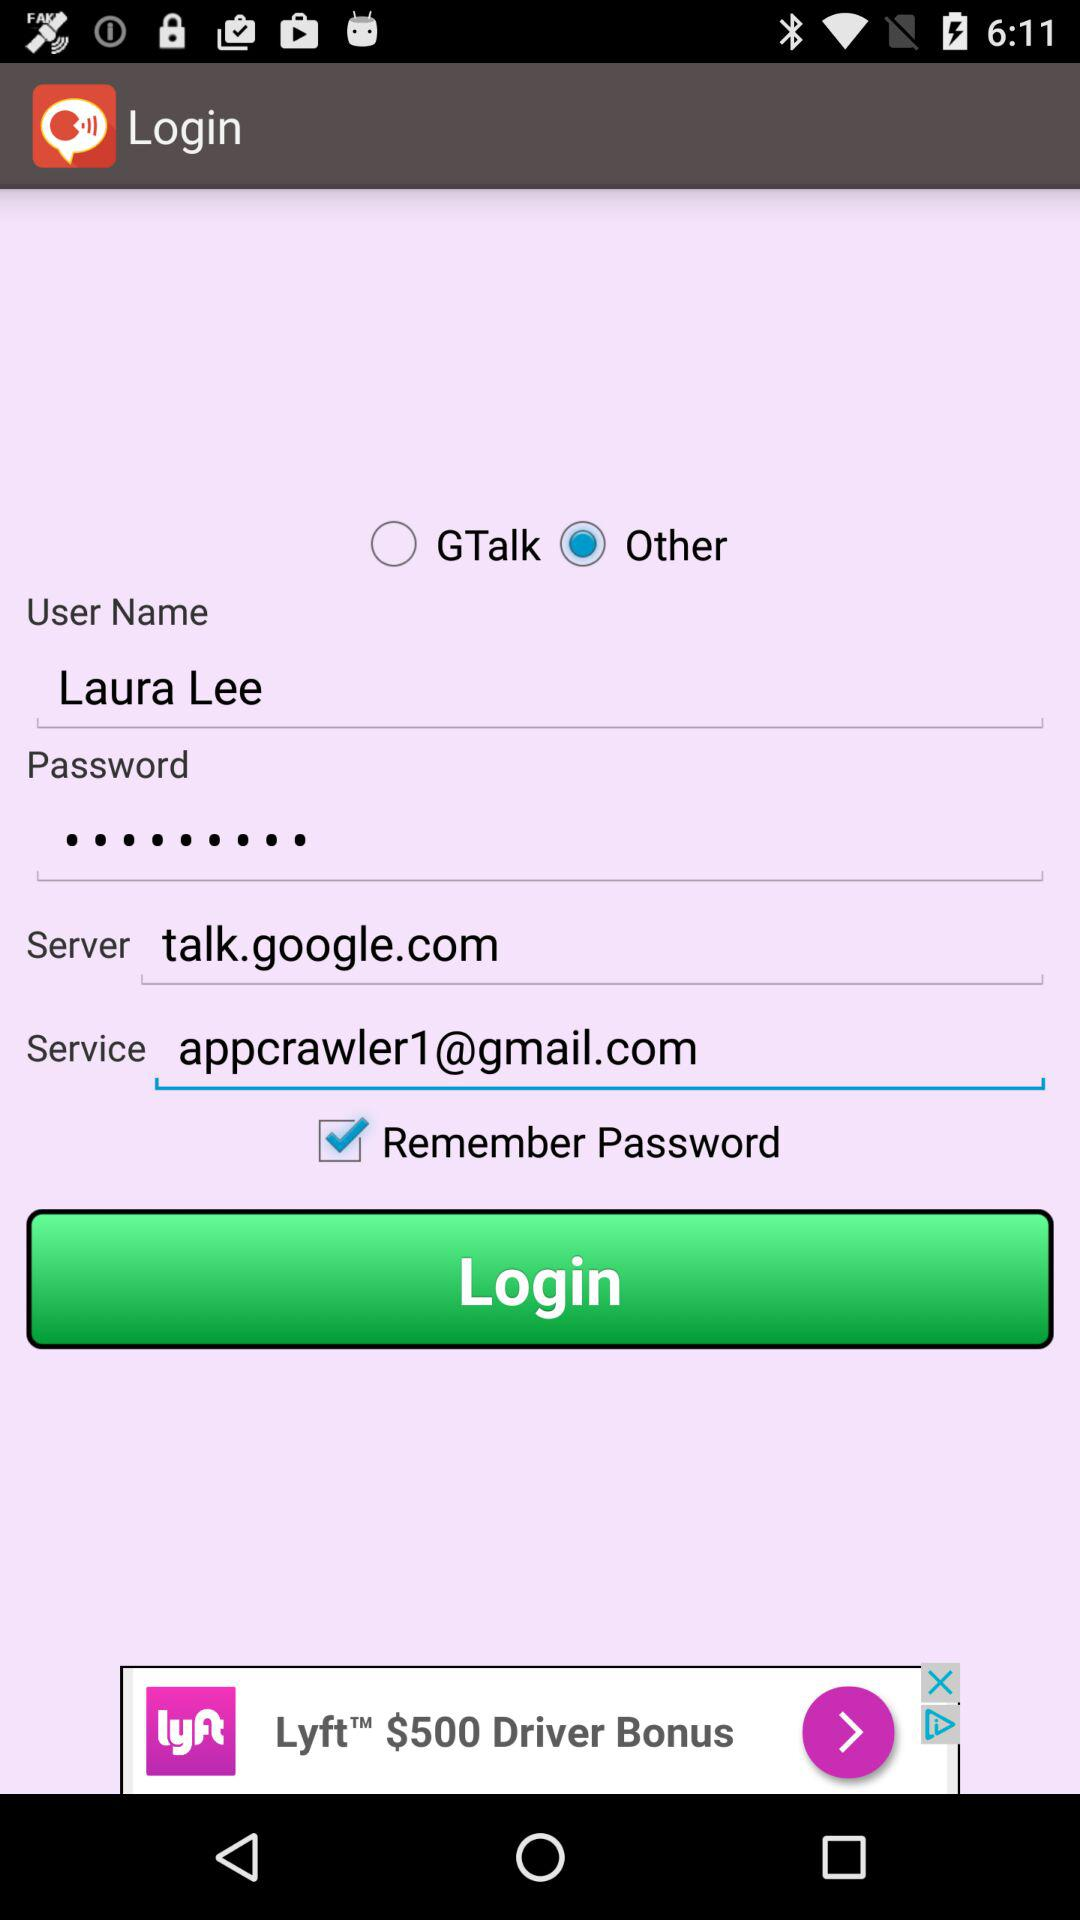What is the server? The server is talk.google.com. 